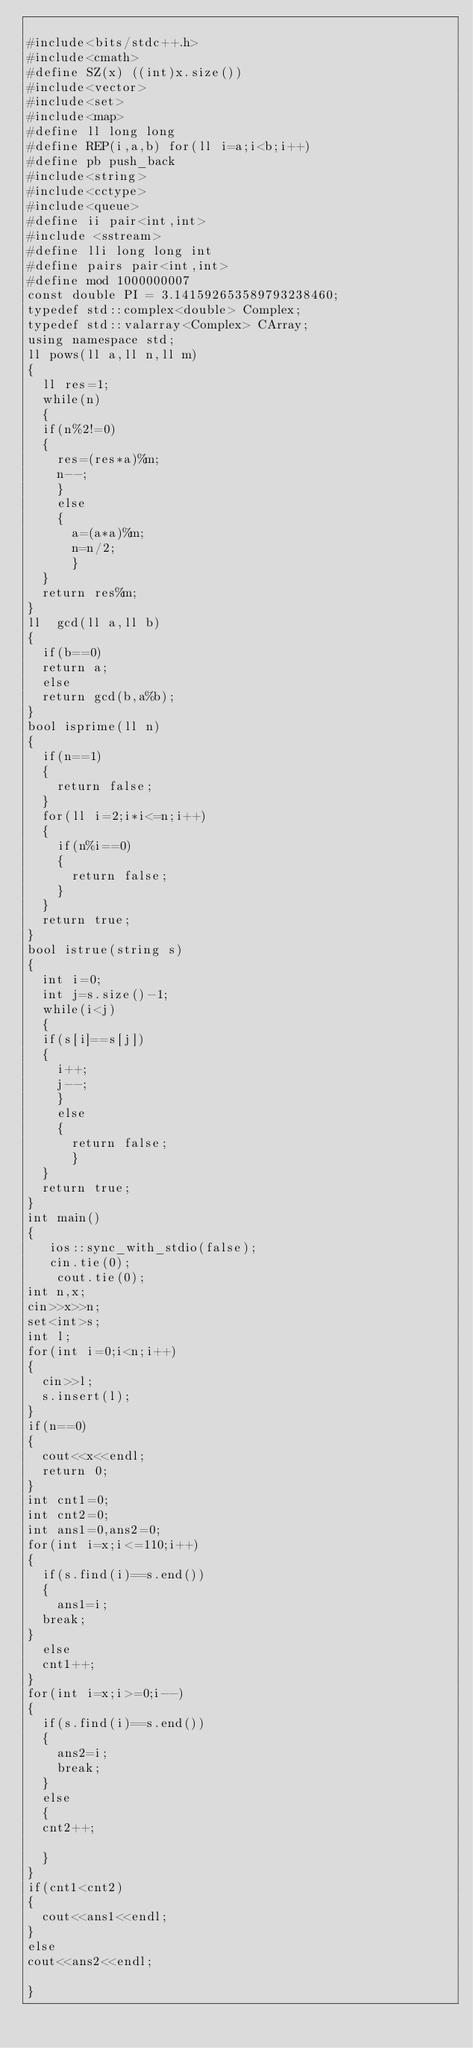Convert code to text. <code><loc_0><loc_0><loc_500><loc_500><_C++_>
#include<bits/stdc++.h>
#include<cmath>
#define SZ(x) ((int)x.size())
#include<vector>
#include<set>
#include<map>
#define ll long long
#define REP(i,a,b) for(ll i=a;i<b;i++)
#define pb push_back
#include<string>
#include<cctype>
#include<queue>
#define ii pair<int,int>
#include <sstream>
#define lli long long int
#define pairs pair<int,int>
#define mod 1000000007
const double PI = 3.141592653589793238460;
typedef std::complex<double> Complex;
typedef std::valarray<Complex> CArray;
using namespace std;
ll pows(ll a,ll n,ll m)
{
	ll res=1;
	while(n)
	{
	if(n%2!=0)
	{
		res=(res*a)%m;
		n--;
		}
		else
		{
			a=(a*a)%m;
			n=n/2;
			}	
	}
	return res%m;
}
ll  gcd(ll a,ll b)
{
	if(b==0)
	return a;
	else 
	return gcd(b,a%b);
}
bool isprime(ll n)
{
	if(n==1)
	{
		return false;
	}
	for(ll i=2;i*i<=n;i++)
	{
		if(n%i==0)
		{
			return false;
		}
	}
	return true;
}
bool istrue(string s)
{
	int i=0;
	int j=s.size()-1;
	while(i<j)
	{
	if(s[i]==s[j])
	{
		i++;
		j--;
		}
		else
		{
			return false;
			}	
	}
	return true;
}
int main()
{
   ios::sync_with_stdio(false);
	 cin.tie(0);
    cout.tie(0);
int n,x;
cin>>x>>n;
set<int>s;
int l;
for(int i=0;i<n;i++)
{
	cin>>l;
	s.insert(l);
}
if(n==0)
{
	cout<<x<<endl;
	return 0;
}
int cnt1=0;
int cnt2=0;
int ans1=0,ans2=0;
for(int i=x;i<=110;i++)
{
	if(s.find(i)==s.end())
	{
		ans1=i;
	break;
}
	else
	cnt1++;
}
for(int i=x;i>=0;i--)
{
	if(s.find(i)==s.end())
	{
		ans2=i;
		break;
	}
	else
	{
	cnt2++;
		
	}
}
if(cnt1<cnt2)
{
	cout<<ans1<<endl;
}
else
cout<<ans2<<endl;
    
}


</code> 